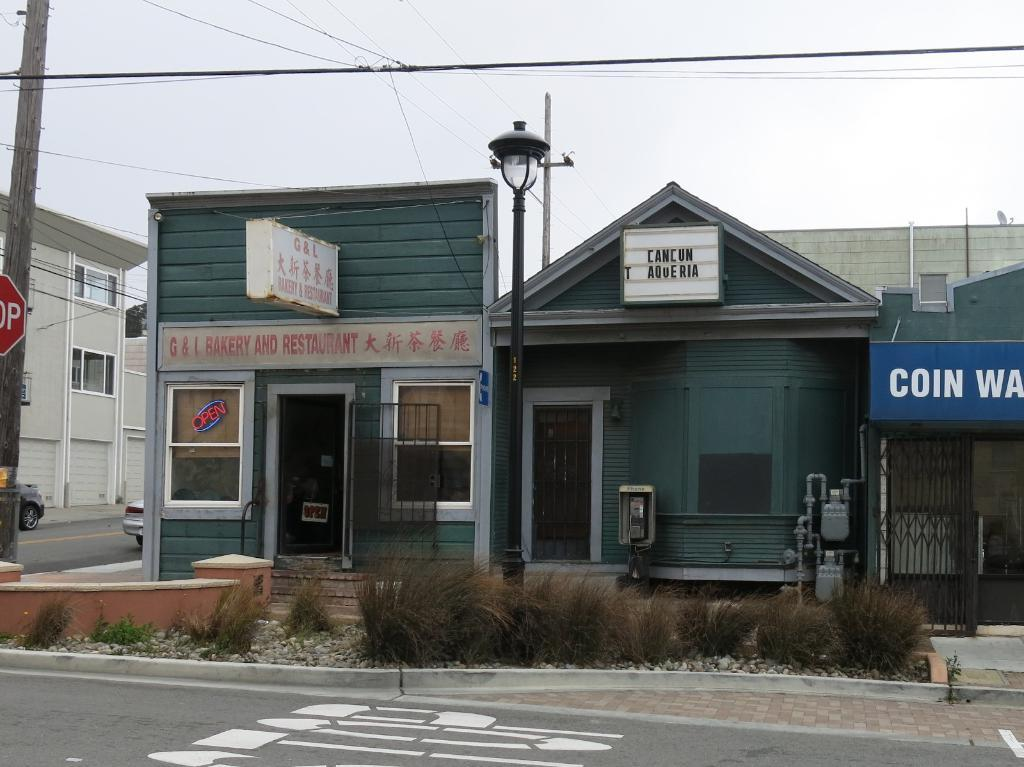What type of structure is in the background of the image? There is a home in the background of the image. Where is the road located in relation to the home? The road is in front of the home. What is on the left side of the image? There is an electric pole on the left side of the image. What can be seen above the electric pole? The sky is visible above the electric pole. How many roses are on the home in the image? There are no roses visible on the home in the image. What type of animal is giving birth on the road in the image? There is no animal or birth scene present in the image; it features a home, a road, an electric pole, and the sky. 